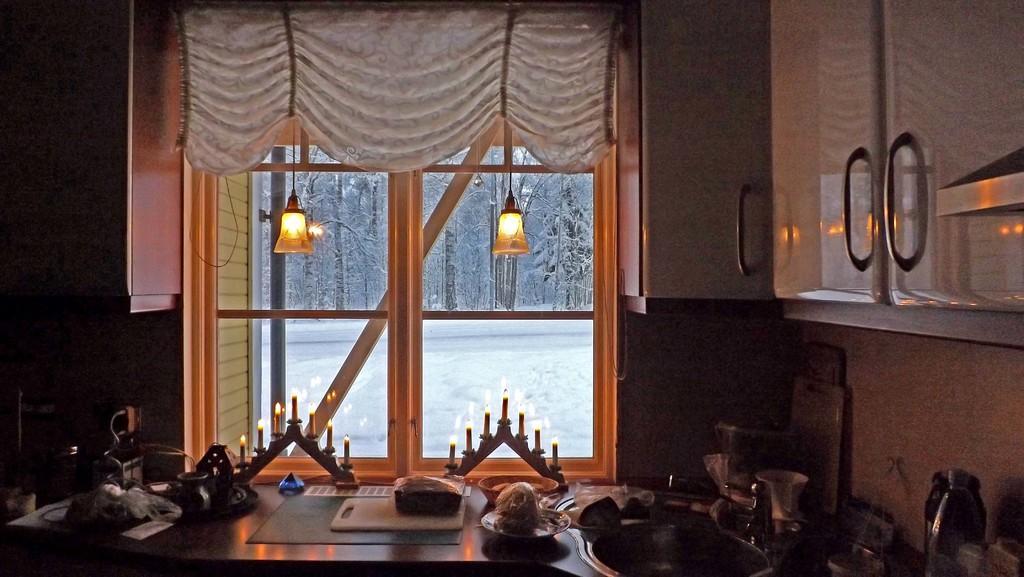In one or two sentences, can you explain what this image depicts? This is an inside picture of a room, in this image we can see a table, on the table, we can see the bowls, candles on the stands and some other objects, also we can see the lights, curtain and a window, through the window, we can see some trees and the snow. 